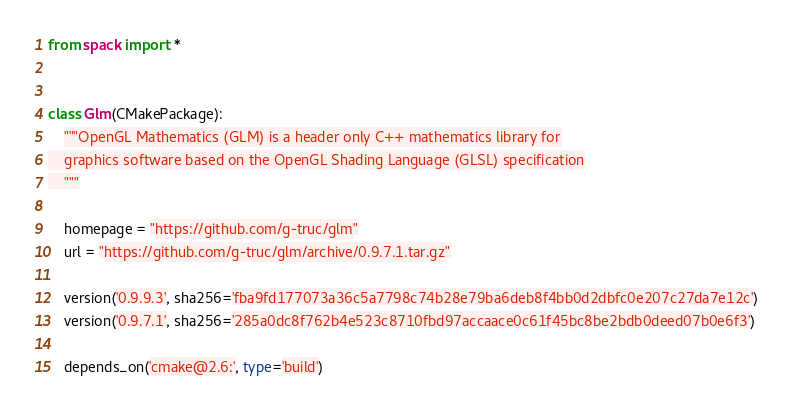Convert code to text. <code><loc_0><loc_0><loc_500><loc_500><_Python_>from spack import *


class Glm(CMakePackage):
    """OpenGL Mathematics (GLM) is a header only C++ mathematics library for
    graphics software based on the OpenGL Shading Language (GLSL) specification
    """

    homepage = "https://github.com/g-truc/glm"
    url = "https://github.com/g-truc/glm/archive/0.9.7.1.tar.gz"

    version('0.9.9.3', sha256='fba9fd177073a36c5a7798c74b28e79ba6deb8f4bb0d2dbfc0e207c27da7e12c')
    version('0.9.7.1', sha256='285a0dc8f762b4e523c8710fbd97accaace0c61f45bc8be2bdb0deed07b0e6f3')

    depends_on('cmake@2.6:', type='build')
</code> 